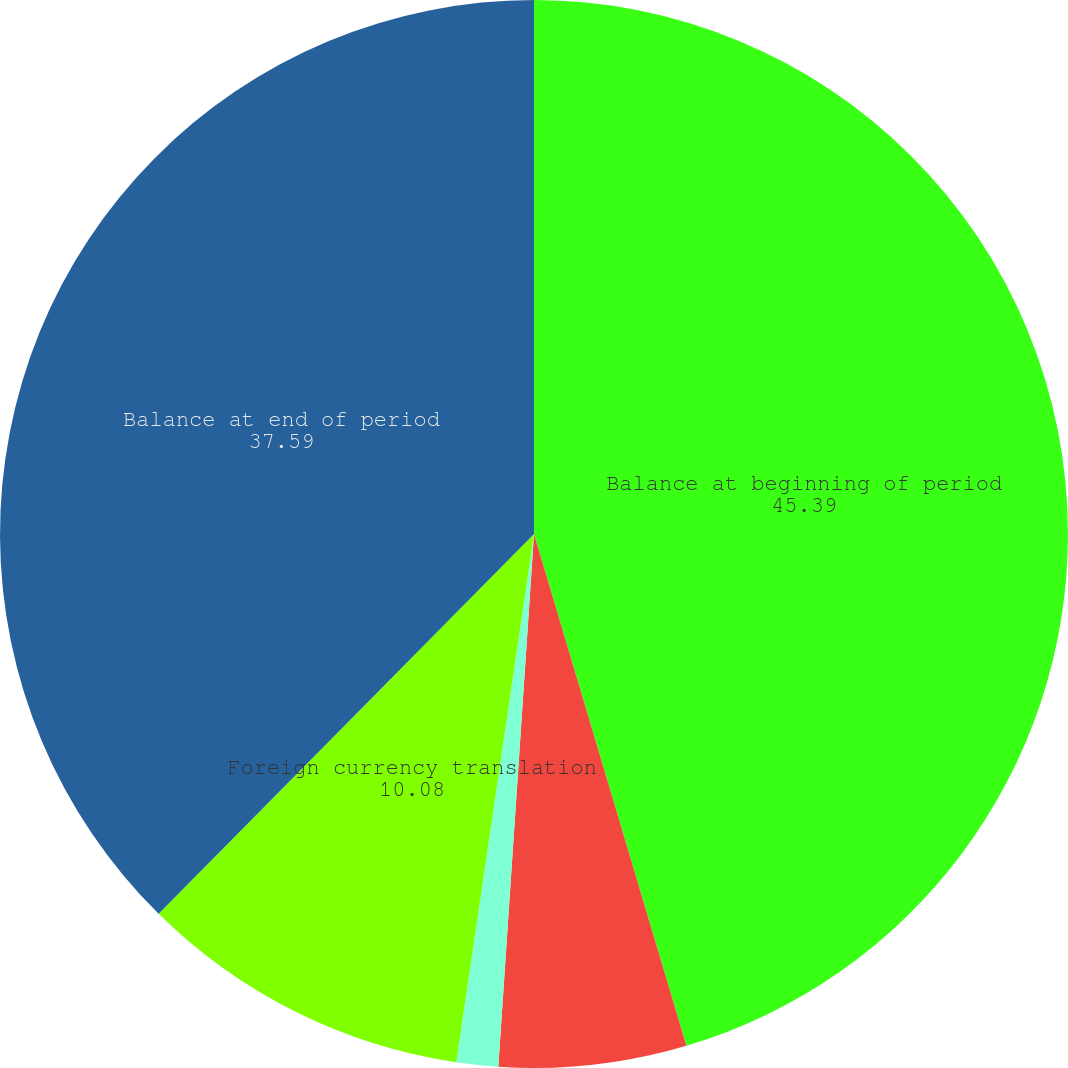Convert chart. <chart><loc_0><loc_0><loc_500><loc_500><pie_chart><fcel>Balance at beginning of period<fcel>Reversed to costs and expenses<fcel>Charged (reversed) to gross<fcel>Foreign currency translation<fcel>Balance at end of period<nl><fcel>45.39%<fcel>5.67%<fcel>1.26%<fcel>10.08%<fcel>37.59%<nl></chart> 